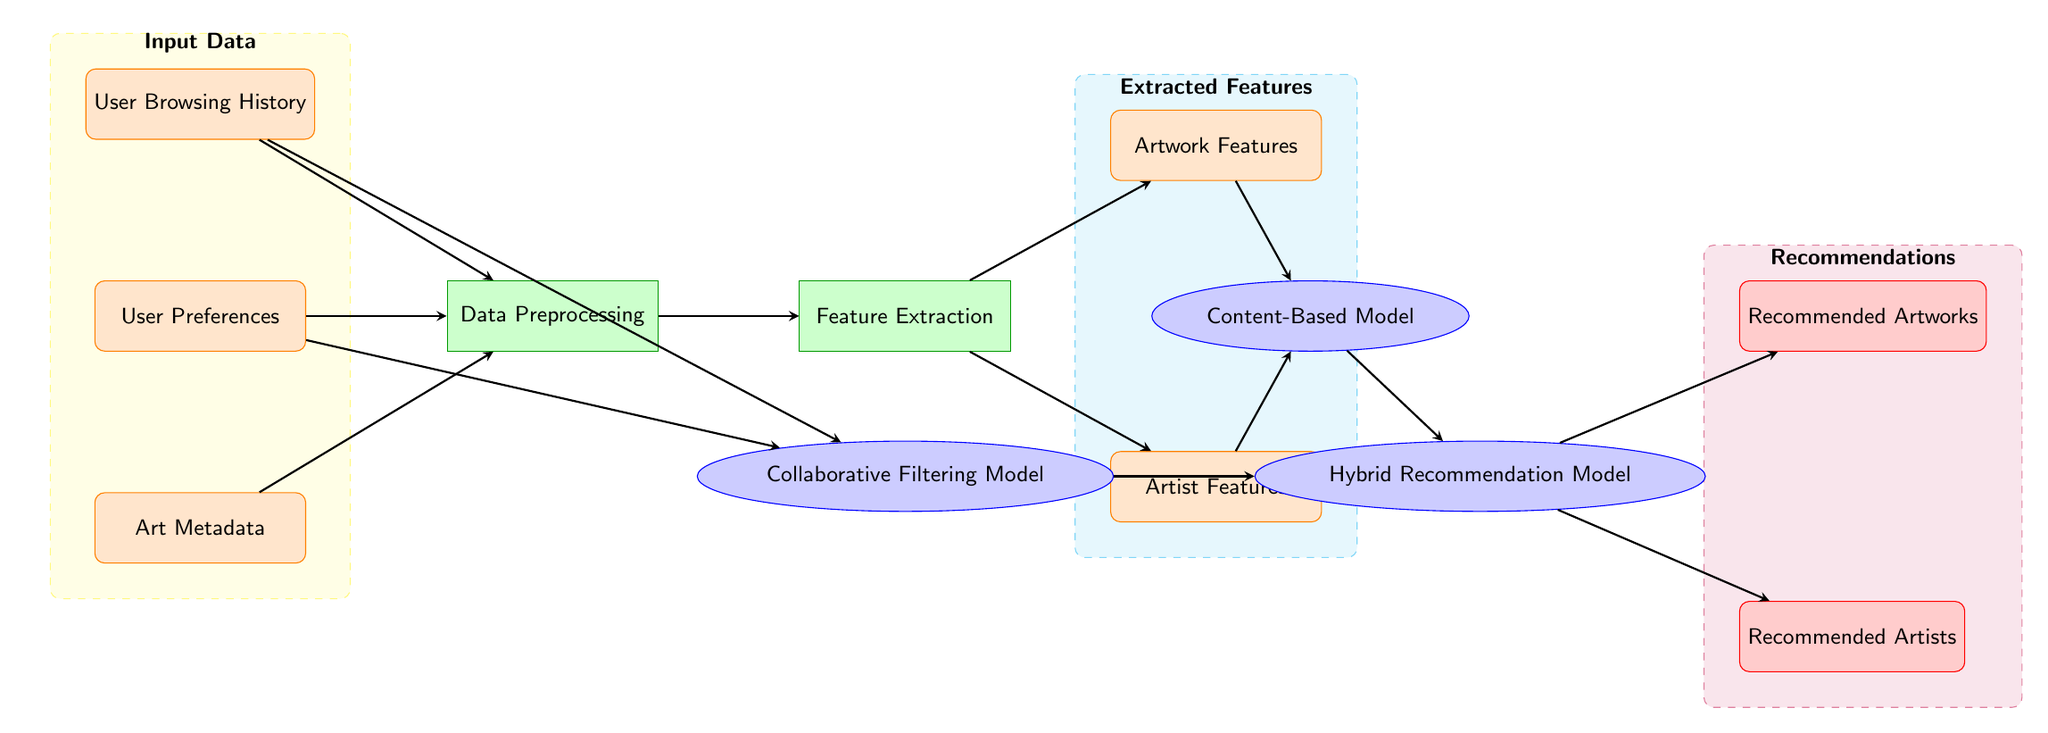What are the input data types in this diagram? The diagram lists three types of user input data: User Browsing History, User Preferences, and Art Metadata. These data types are represented as data nodes at the top of the diagram, showing their role as input data.
Answer: User Browsing History, User Preferences, Art Metadata How many models are present in the diagram? The diagram indicates three distinct models: Collaborative Filtering Model, Content-Based Model, and Hybrid Recommendation Model. These are represented as ellipse-shaped nodes along the processing path.
Answer: Three Which process directly follows Data Preprocessing? The diagram shows that after Data Preprocessing, the next step is Feature Extraction, which is indicated by an arrow proceeding to the Feature Extraction node from the Data Preprocessing node.
Answer: Feature Extraction What do the output nodes represent? The output nodes symbolize the final recommendations generated by the system, specifically recommended artworks and recommended artists, as indicated by their respective labels.
Answer: Recommended Artworks, Recommended Artists What features are extracted during the processing? During the processing step, Artwork Features and Artist Features are extracted as highlighted data nodes following Feature Extraction, exceeding the system's capability to provide recommendations.
Answer: Artwork Features, Artist Features How does the Hybrid Recommendation Model relate to the other models? The Hybrid Recommendation Model combines outputs from both the Collaborative Filtering Model and the Content-Based Model as indicated by the arrows leading into it from both models, illustrating a collaborative approach in generating recommendations.
Answer: It combines outputs from both models What is the purpose of the Data Preprocessing step? The Data Preprocessing step organizes, cleans, and prepares the input data (User Browsing History, User Preferences, Art Metadata) so that it can be effectively used in the subsequent feature extraction and modeling phases.
Answer: To prepare input data for analysis What are the two main categories of features extracted in the diagram? The diagram separates features into two main categories: Artwork Features and Artist Features, each represented by distinct data nodes, indicating that the system considers both types of information for recommendations.
Answer: Artwork Features, Artist Features 